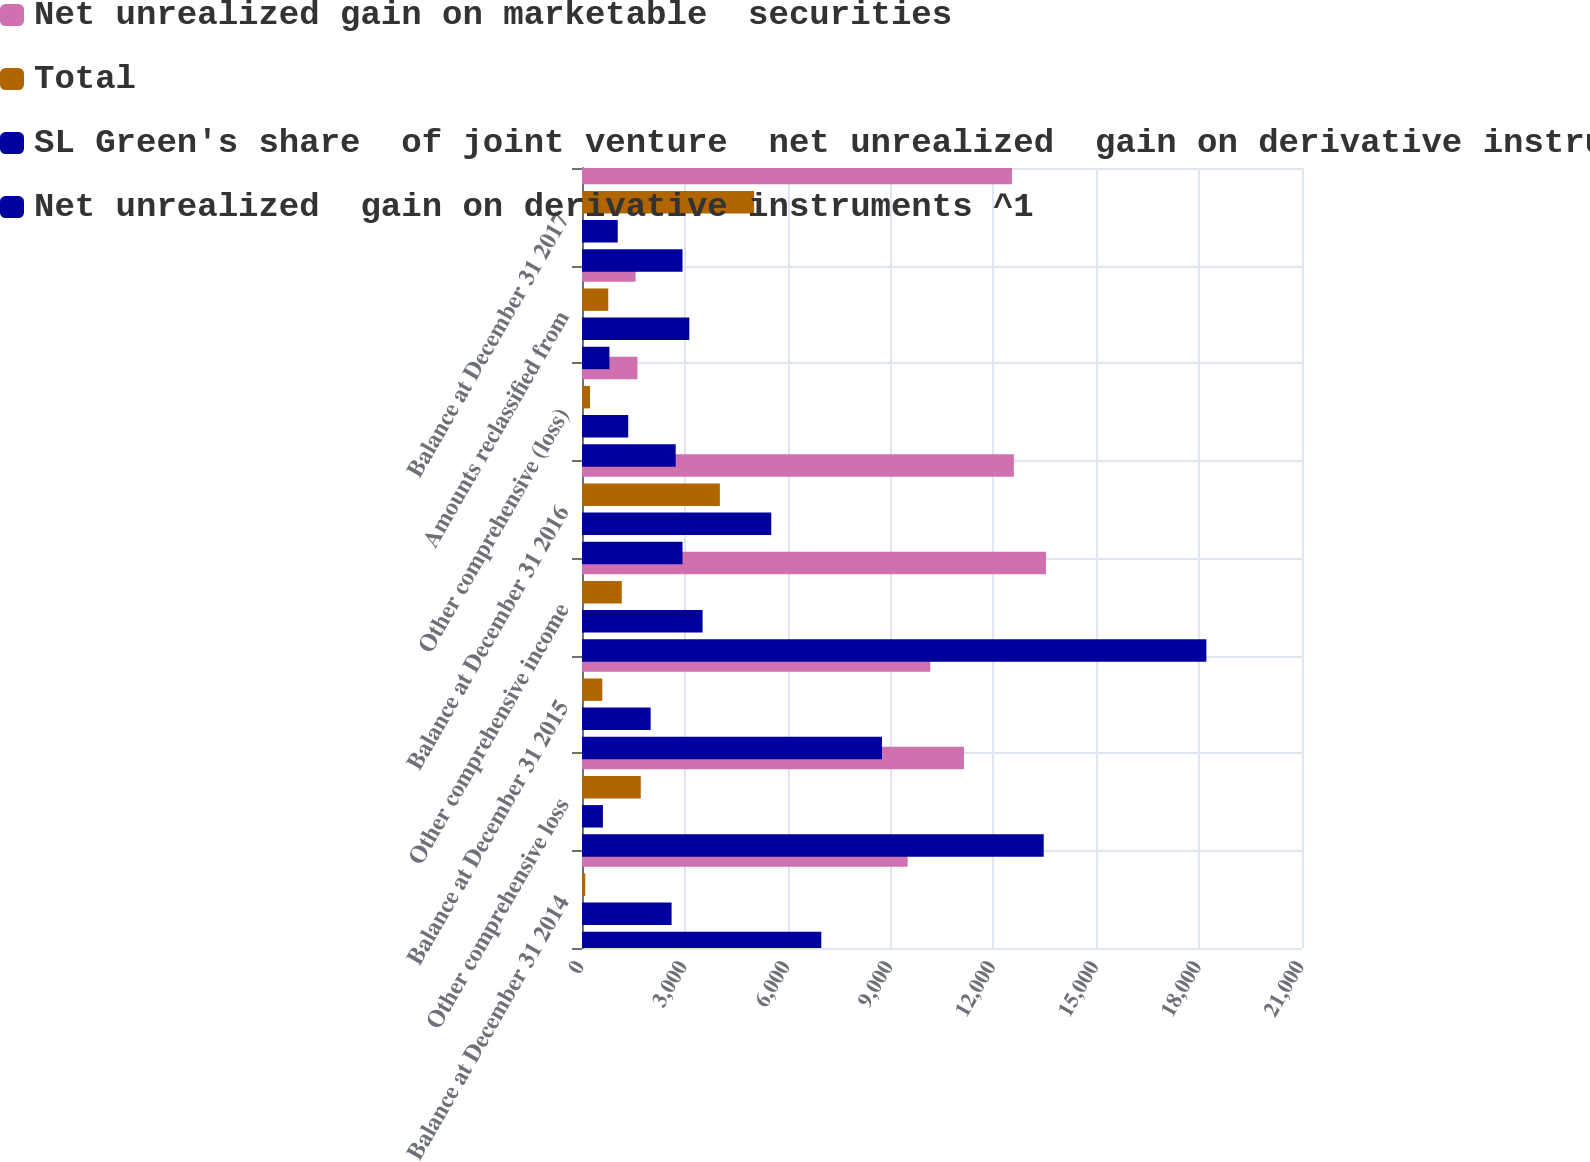<chart> <loc_0><loc_0><loc_500><loc_500><stacked_bar_chart><ecel><fcel>Balance at December 31 2014<fcel>Other comprehensive loss<fcel>Balance at December 31 2015<fcel>Other comprehensive income<fcel>Balance at December 31 2016<fcel>Other comprehensive (loss)<fcel>Amounts reclassified from<fcel>Balance at December 31 2017<nl><fcel>Net unrealized gain on marketable  securities<fcel>9498<fcel>11143<fcel>10160<fcel>13534<fcel>12596<fcel>1618<fcel>1564<fcel>12542<nl><fcel>Total<fcel>95<fcel>1714<fcel>592<fcel>1160<fcel>4021<fcel>233<fcel>766<fcel>5020<nl><fcel>SL Green's share  of joint venture  net unrealized  gain on derivative instruments ^2<fcel>2613<fcel>610<fcel>2003<fcel>3517<fcel>5520<fcel>1348<fcel>3130<fcel>1042<nl><fcel>Net unrealized  gain on derivative instruments ^1<fcel>6980<fcel>13467<fcel>8749<fcel>18211<fcel>2931.5<fcel>2733<fcel>800<fcel>2931.5<nl></chart> 